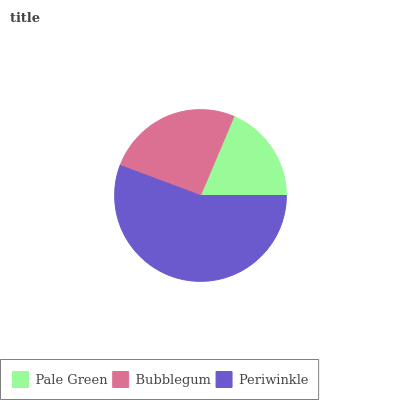Is Pale Green the minimum?
Answer yes or no. Yes. Is Periwinkle the maximum?
Answer yes or no. Yes. Is Bubblegum the minimum?
Answer yes or no. No. Is Bubblegum the maximum?
Answer yes or no. No. Is Bubblegum greater than Pale Green?
Answer yes or no. Yes. Is Pale Green less than Bubblegum?
Answer yes or no. Yes. Is Pale Green greater than Bubblegum?
Answer yes or no. No. Is Bubblegum less than Pale Green?
Answer yes or no. No. Is Bubblegum the high median?
Answer yes or no. Yes. Is Bubblegum the low median?
Answer yes or no. Yes. Is Periwinkle the high median?
Answer yes or no. No. Is Pale Green the low median?
Answer yes or no. No. 